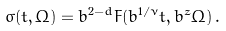<formula> <loc_0><loc_0><loc_500><loc_500>\sigma ( t , \Omega ) = b ^ { 2 - d } F ( b ^ { 1 / \nu } t , b ^ { z } \Omega ) \, .</formula> 